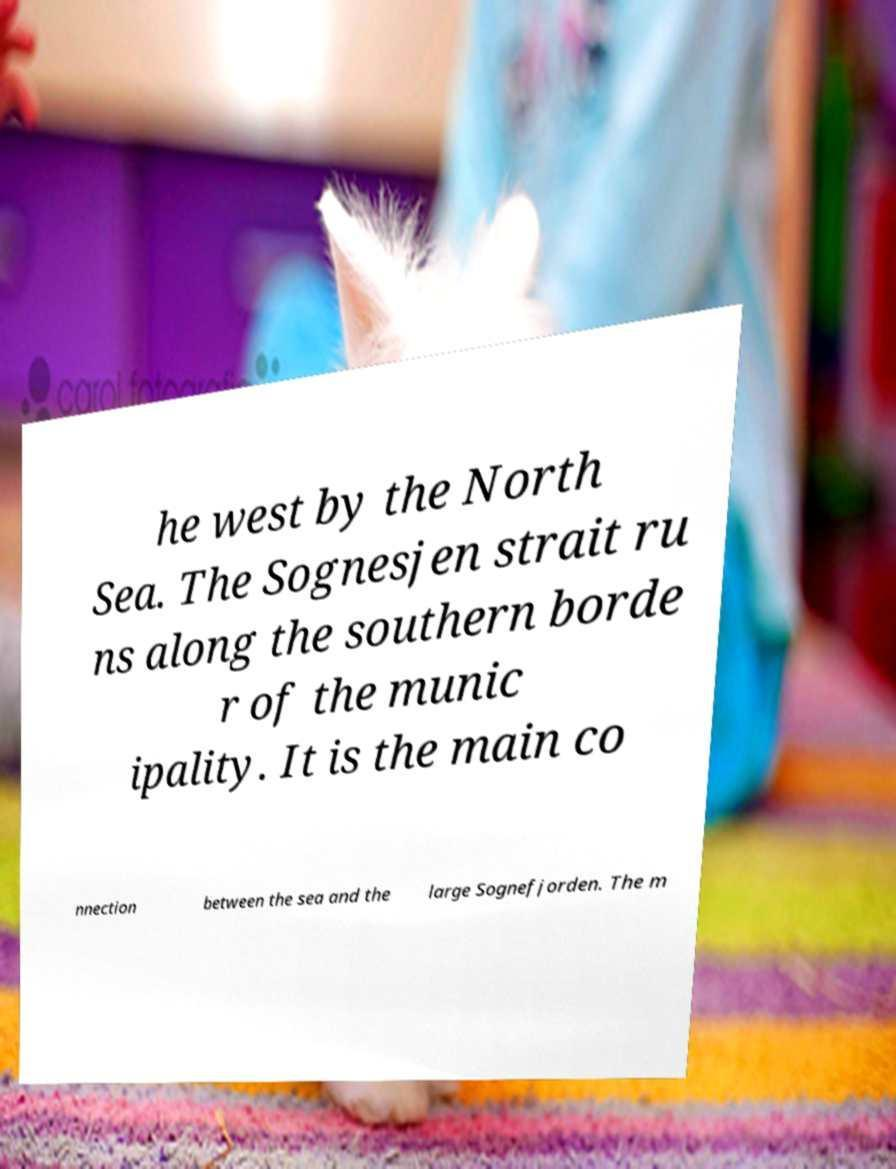There's text embedded in this image that I need extracted. Can you transcribe it verbatim? he west by the North Sea. The Sognesjen strait ru ns along the southern borde r of the munic ipality. It is the main co nnection between the sea and the large Sognefjorden. The m 